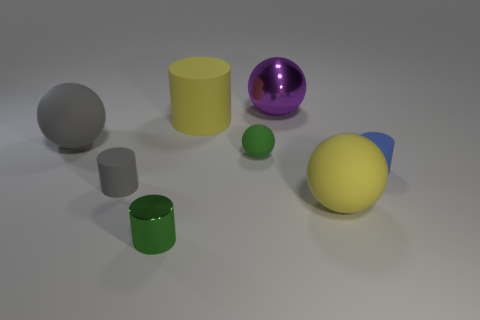Are there any gray matte things of the same shape as the purple thing?
Your response must be concise. Yes. Is the small green cylinder made of the same material as the big thing in front of the big gray rubber thing?
Keep it short and to the point. No. What is the color of the cylinder on the right side of the tiny green thing that is behind the rubber ball to the right of the large metallic ball?
Your answer should be compact. Blue. What material is the purple object that is the same size as the yellow rubber cylinder?
Give a very brief answer. Metal. What number of yellow spheres are made of the same material as the gray cylinder?
Make the answer very short. 1. Do the cylinder that is right of the large purple metallic sphere and the gray matte object behind the tiny gray rubber object have the same size?
Your response must be concise. No. There is a large thing that is in front of the small green sphere; what color is it?
Keep it short and to the point. Yellow. There is a small thing that is the same color as the tiny metallic cylinder; what is its material?
Keep it short and to the point. Rubber. What number of small things have the same color as the small ball?
Your answer should be compact. 1. There is a shiny cylinder; does it have the same size as the yellow object in front of the small green sphere?
Keep it short and to the point. No. 